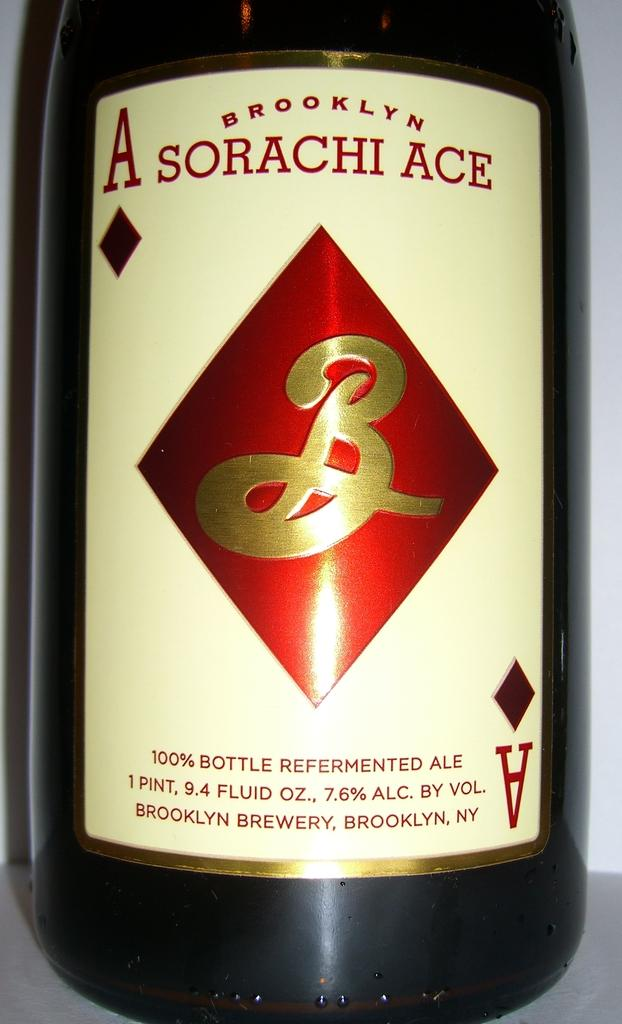<image>
Share a concise interpretation of the image provided. A bottle of Brooklyn Ace 100% Refermented Ale. 